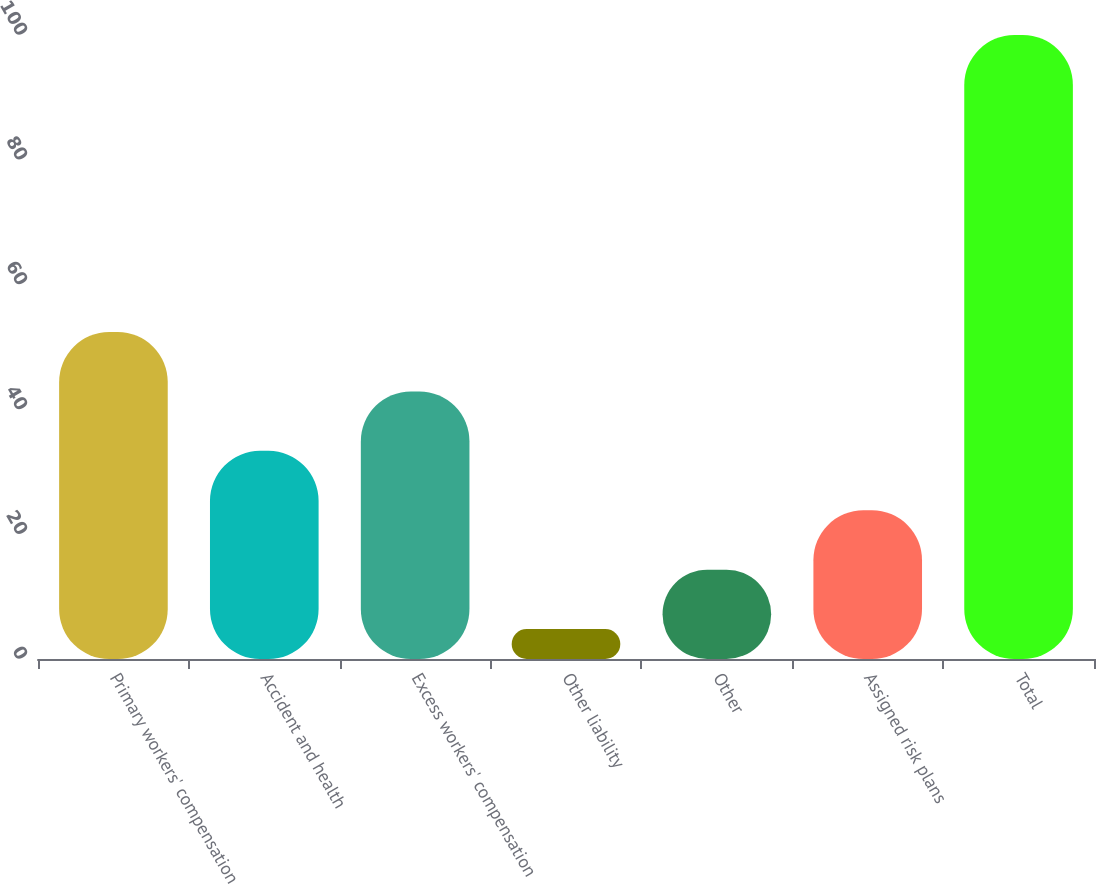Convert chart. <chart><loc_0><loc_0><loc_500><loc_500><bar_chart><fcel>Primary workers' compensation<fcel>Accident and health<fcel>Excess workers' compensation<fcel>Other liability<fcel>Other<fcel>Assigned risk plans<fcel>Total<nl><fcel>52.4<fcel>33.36<fcel>42.88<fcel>4.8<fcel>14.32<fcel>23.84<fcel>100<nl></chart> 